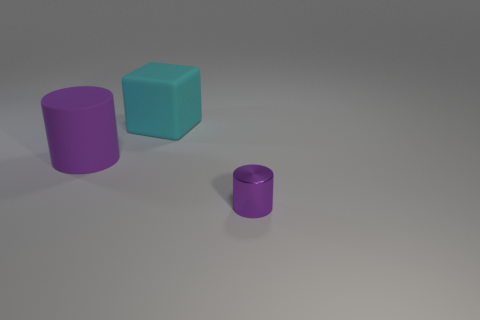What size is the other cylinder that is the same color as the rubber cylinder?
Give a very brief answer. Small. What material is the small object that is the same color as the big cylinder?
Your answer should be very brief. Metal. There is a cylinder behind the tiny purple metal cylinder; does it have the same color as the thing that is to the right of the large matte cube?
Your answer should be very brief. Yes. Are the cylinder that is right of the cyan thing and the purple cylinder left of the big matte block made of the same material?
Give a very brief answer. No. Is there a large matte cylinder that is behind the big object that is behind the big matte cylinder?
Your response must be concise. No. What number of big blocks are on the left side of the tiny purple cylinder?
Your answer should be very brief. 1. How many other things are there of the same color as the rubber block?
Your response must be concise. 0. Is the number of small purple objects on the left side of the tiny purple thing less than the number of large matte things behind the large purple cylinder?
Provide a short and direct response. Yes. How many objects are either objects that are behind the tiny purple metal thing or purple things?
Provide a short and direct response. 3. Does the purple rubber object have the same size as the object behind the purple matte object?
Give a very brief answer. Yes. 